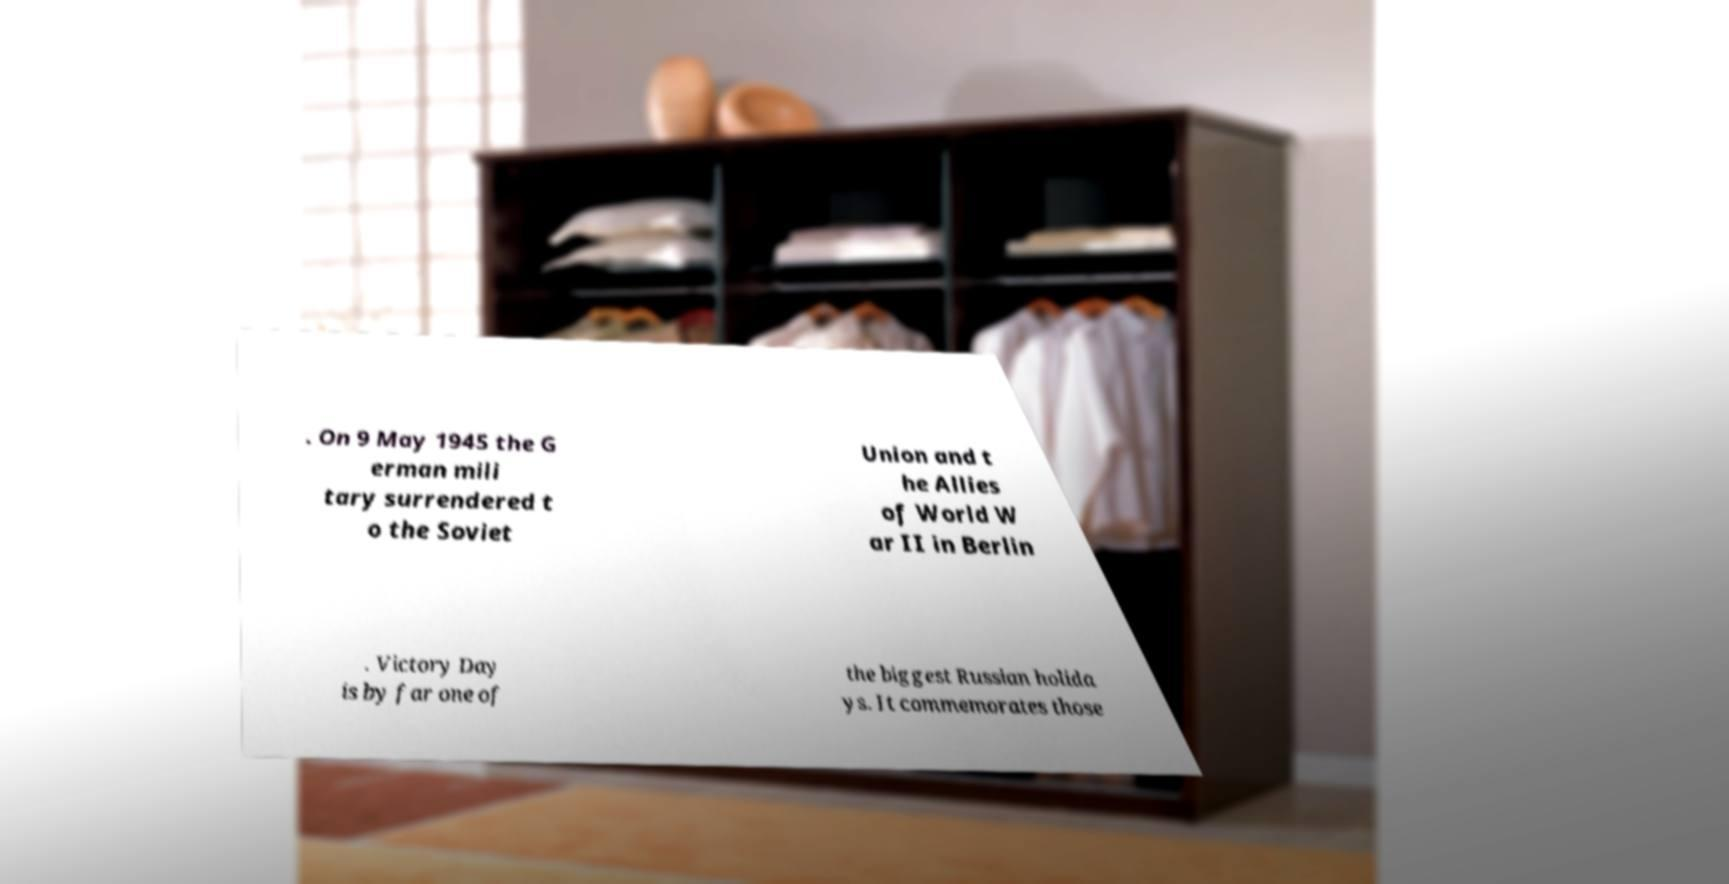Can you accurately transcribe the text from the provided image for me? . On 9 May 1945 the G erman mili tary surrendered t o the Soviet Union and t he Allies of World W ar II in Berlin . Victory Day is by far one of the biggest Russian holida ys. It commemorates those 